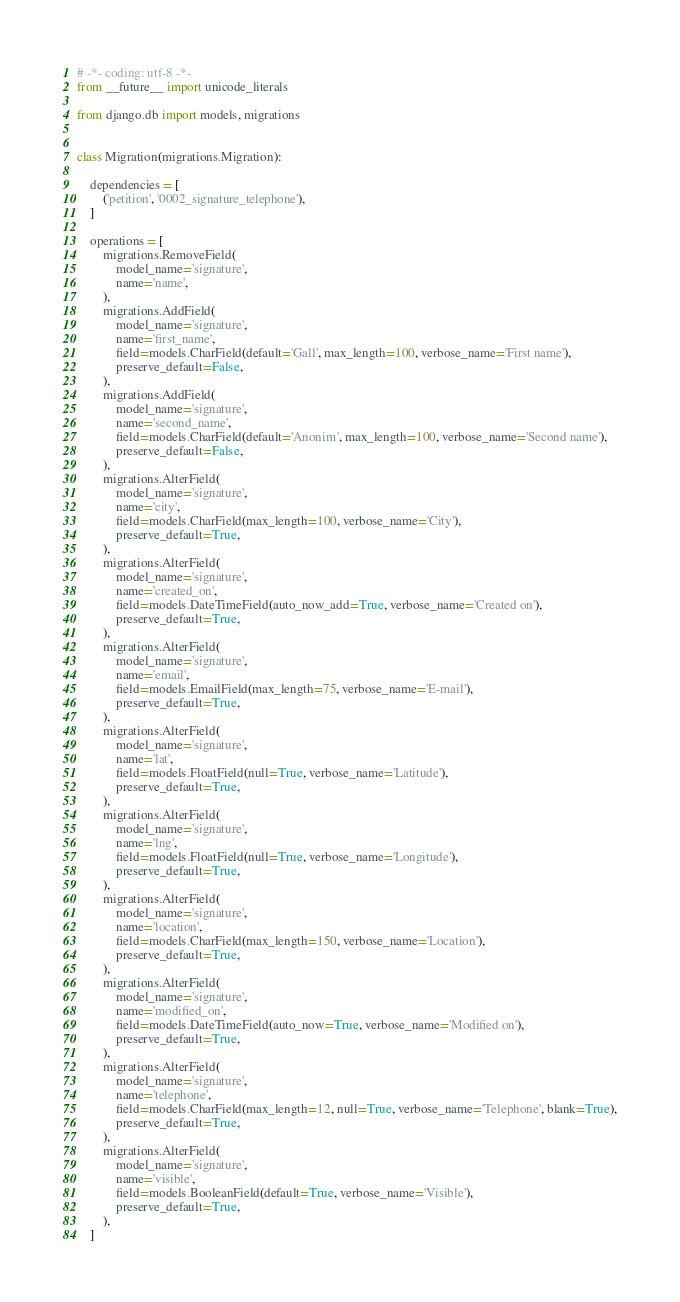Convert code to text. <code><loc_0><loc_0><loc_500><loc_500><_Python_># -*- coding: utf-8 -*-
from __future__ import unicode_literals

from django.db import models, migrations


class Migration(migrations.Migration):

    dependencies = [
        ('petition', '0002_signature_telephone'),
    ]

    operations = [
        migrations.RemoveField(
            model_name='signature',
            name='name',
        ),
        migrations.AddField(
            model_name='signature',
            name='first_name',
            field=models.CharField(default='Gall', max_length=100, verbose_name='First name'),
            preserve_default=False,
        ),
        migrations.AddField(
            model_name='signature',
            name='second_name',
            field=models.CharField(default='Anonim', max_length=100, verbose_name='Second name'),
            preserve_default=False,
        ),
        migrations.AlterField(
            model_name='signature',
            name='city',
            field=models.CharField(max_length=100, verbose_name='City'),
            preserve_default=True,
        ),
        migrations.AlterField(
            model_name='signature',
            name='created_on',
            field=models.DateTimeField(auto_now_add=True, verbose_name='Created on'),
            preserve_default=True,
        ),
        migrations.AlterField(
            model_name='signature',
            name='email',
            field=models.EmailField(max_length=75, verbose_name='E-mail'),
            preserve_default=True,
        ),
        migrations.AlterField(
            model_name='signature',
            name='lat',
            field=models.FloatField(null=True, verbose_name='Latitude'),
            preserve_default=True,
        ),
        migrations.AlterField(
            model_name='signature',
            name='lng',
            field=models.FloatField(null=True, verbose_name='Longitude'),
            preserve_default=True,
        ),
        migrations.AlterField(
            model_name='signature',
            name='location',
            field=models.CharField(max_length=150, verbose_name='Location'),
            preserve_default=True,
        ),
        migrations.AlterField(
            model_name='signature',
            name='modified_on',
            field=models.DateTimeField(auto_now=True, verbose_name='Modified on'),
            preserve_default=True,
        ),
        migrations.AlterField(
            model_name='signature',
            name='telephone',
            field=models.CharField(max_length=12, null=True, verbose_name='Telephone', blank=True),
            preserve_default=True,
        ),
        migrations.AlterField(
            model_name='signature',
            name='visible',
            field=models.BooleanField(default=True, verbose_name='Visible'),
            preserve_default=True,
        ),
    ]
</code> 